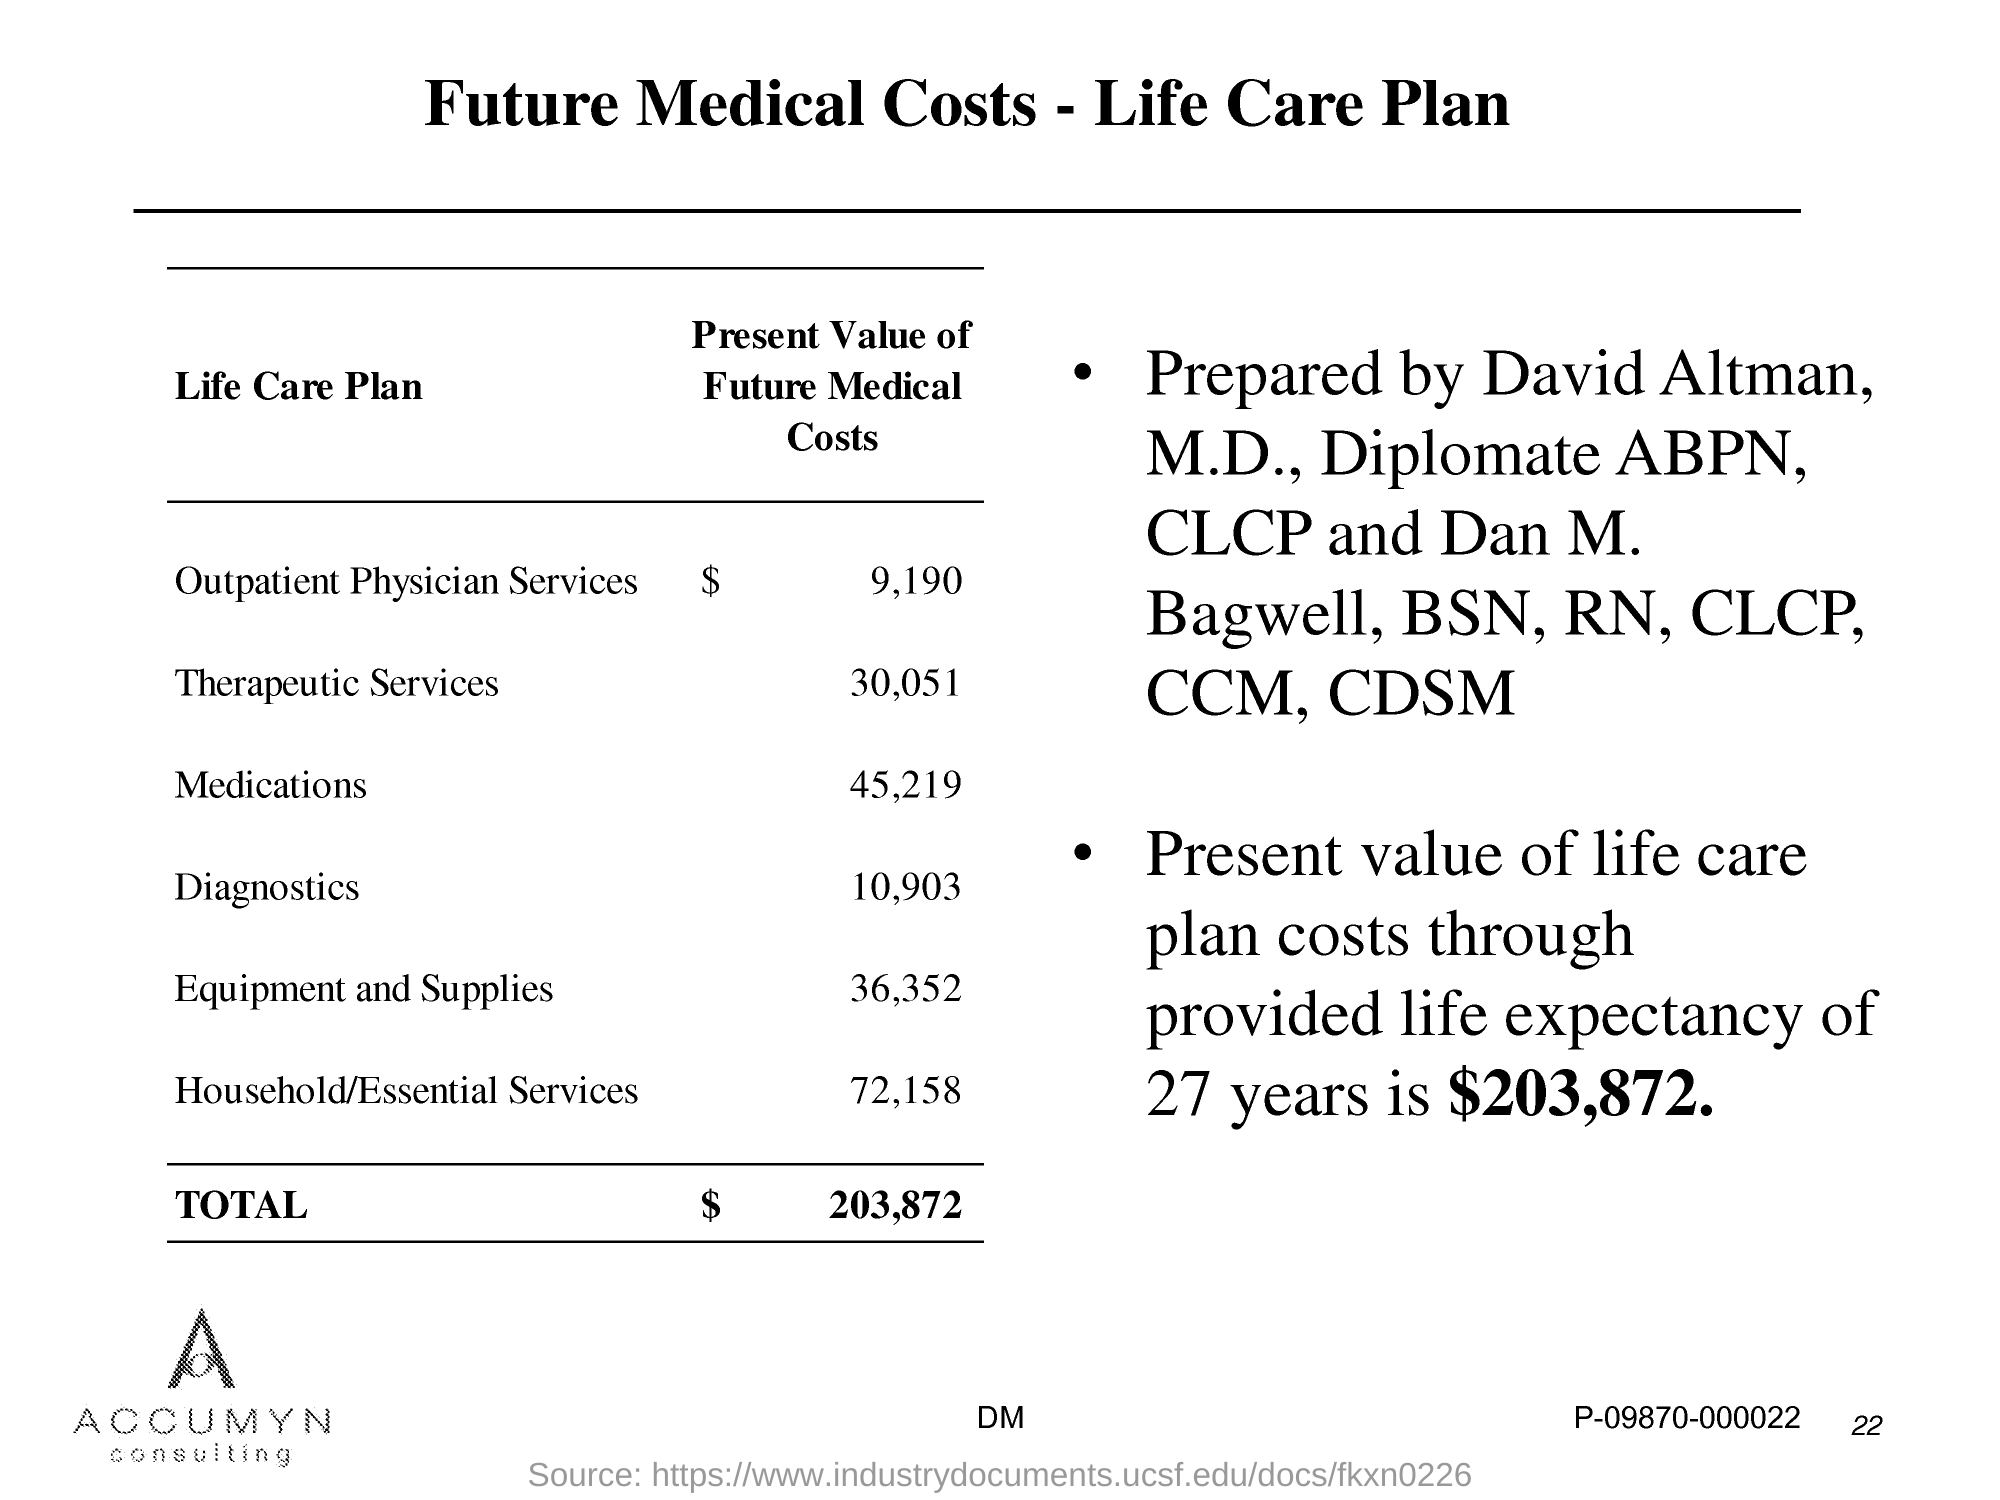What is the title of this document?
Give a very brief answer. Future Medical Costs - Life Care Plan. 